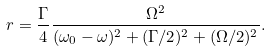<formula> <loc_0><loc_0><loc_500><loc_500>r = \frac { \Gamma } { 4 } \frac { \Omega ^ { 2 } } { ( \omega _ { 0 } - \omega ) ^ { 2 } + ( \Gamma / 2 ) ^ { 2 } + ( \Omega / 2 ) ^ { 2 } } .</formula> 